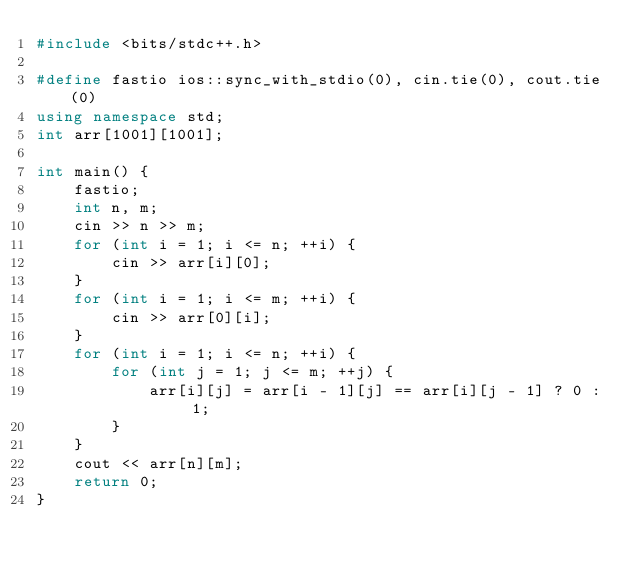Convert code to text. <code><loc_0><loc_0><loc_500><loc_500><_C++_>#include <bits/stdc++.h>

#define fastio ios::sync_with_stdio(0), cin.tie(0), cout.tie(0)
using namespace std;
int arr[1001][1001];

int main() {
    fastio;
    int n, m;
    cin >> n >> m;
    for (int i = 1; i <= n; ++i) {
        cin >> arr[i][0];
    }
    for (int i = 1; i <= m; ++i) {
        cin >> arr[0][i];
    }
    for (int i = 1; i <= n; ++i) {
        for (int j = 1; j <= m; ++j) {
            arr[i][j] = arr[i - 1][j] == arr[i][j - 1] ? 0 : 1;
        }
    }
    cout << arr[n][m];
    return 0;
}</code> 